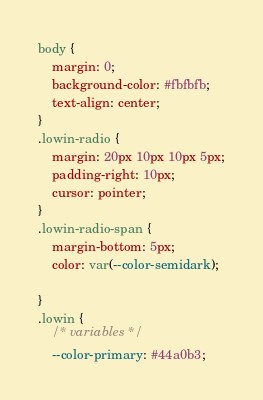Convert code to text. <code><loc_0><loc_0><loc_500><loc_500><_CSS_>body {
	margin: 0;
	background-color: #fbfbfb;
	text-align: center;
}
.lowin-radio {
	margin: 20px 10px 10px 5px;
	padding-right: 10px;
	cursor: pointer;
}
.lowin-radio-span {
	margin-bottom: 5px;
	color: var(--color-semidark);

}
.lowin {
	/* variables */
	--color-primary: #44a0b3;</code> 